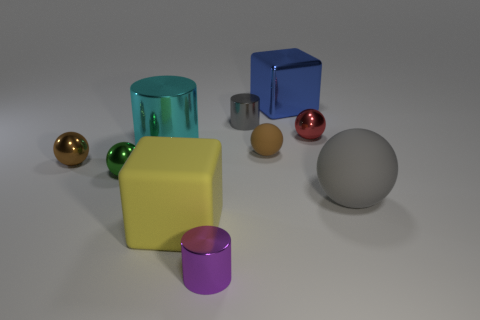Does the large sphere have the same color as the small shiny cylinder behind the tiny red object?
Provide a short and direct response. Yes. Are there any purple cylinders in front of the small gray metallic cylinder?
Provide a short and direct response. Yes. Are the small green thing and the gray cylinder made of the same material?
Your answer should be very brief. Yes. There is a gray object that is the same size as the blue shiny thing; what is its material?
Provide a short and direct response. Rubber. What number of things are big things that are behind the small gray cylinder or purple cylinders?
Keep it short and to the point. 2. Is the number of shiny things behind the big rubber sphere the same as the number of yellow cubes?
Your answer should be compact. No. What color is the thing that is both right of the yellow rubber thing and in front of the large sphere?
Give a very brief answer. Purple. What number of cylinders are either small purple metallic things or tiny brown shiny objects?
Offer a terse response. 1. Are there fewer shiny cylinders that are in front of the red metal thing than big metal cylinders?
Ensure brevity in your answer.  No. There is a tiny green thing that is the same material as the large cylinder; what shape is it?
Keep it short and to the point. Sphere. 